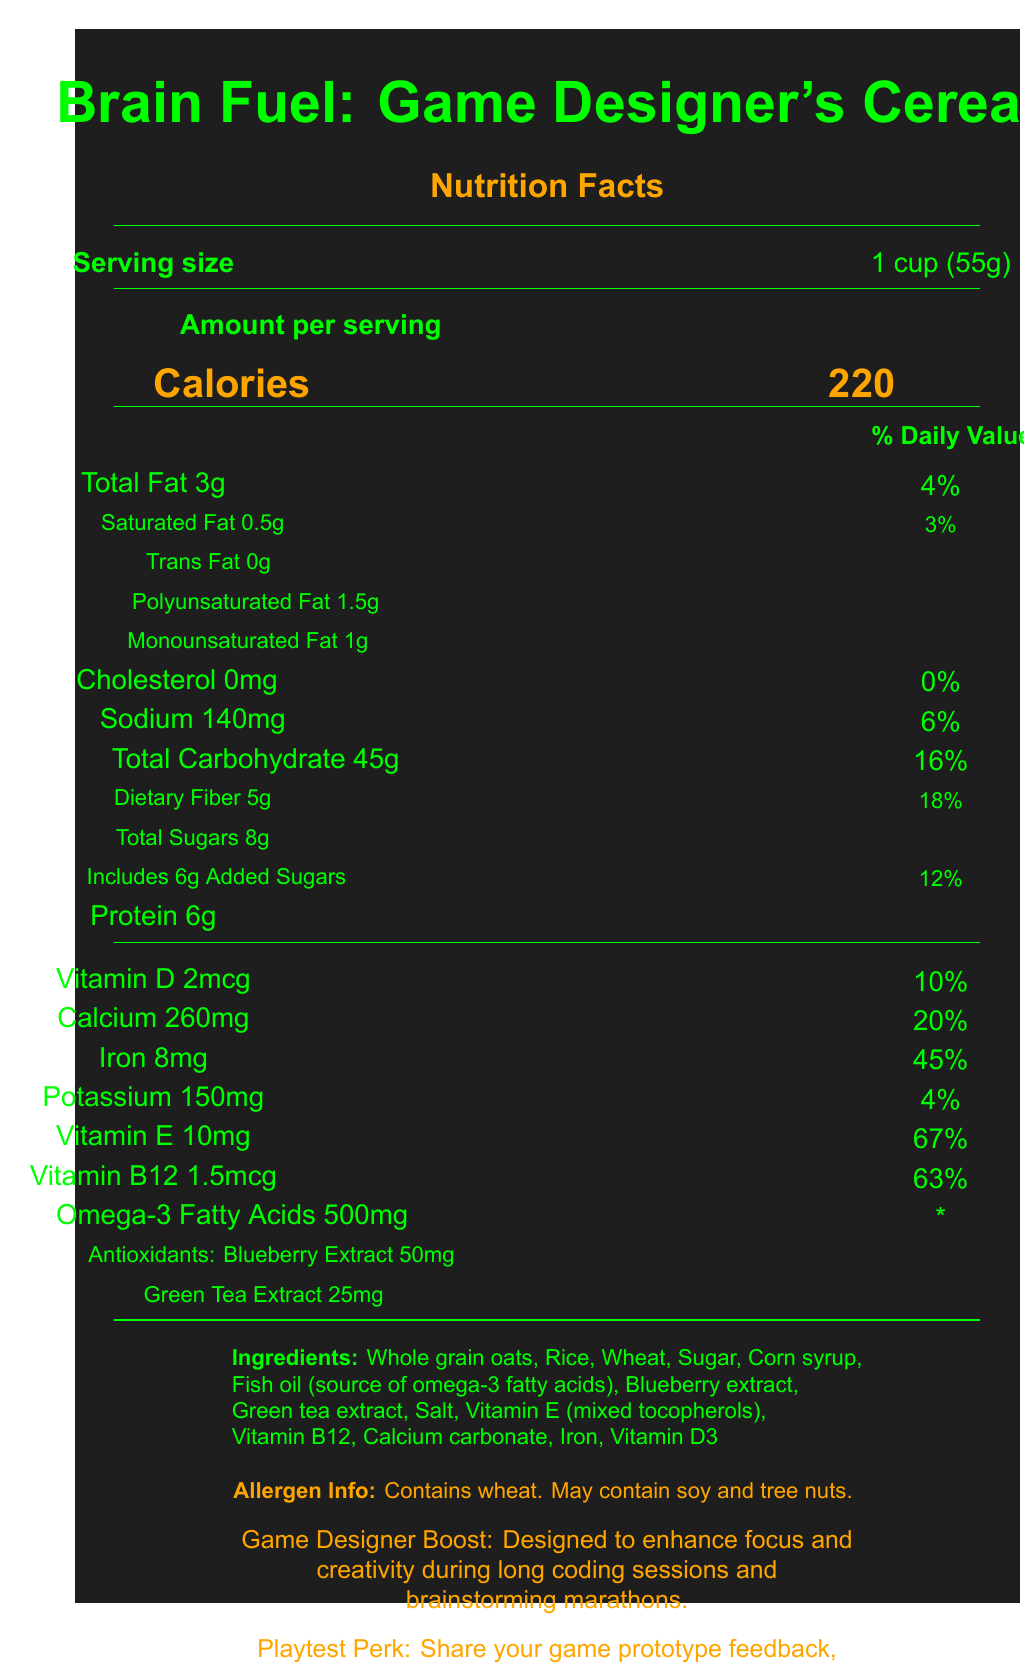what is the serving size? The serving size is explicitly listed as "1 cup (55g)" on the document.
Answer: 1 cup (55g) how many calories are there per serving? The calories per serving are clearly indicated as "220" in a large font.
Answer: 220 how much Vitamin B12 is in one serving? The document lists "Vitamin B12 1.5mcg" with a daily value percentage of 63%.
Answer: 1.5mcg how many grams of total fat are in one serving? The document states "Total Fat 3g" with a daily value percentage of 4%.
Answer: 3g which ingredient is the source of omega-3 fatty acids? The ingredient list includes "Fish oil (source of omega-3 fatty acids)".
Answer: Fish oil how much iron is in one serving? The document lists "Iron 8mg" with a daily value percentage of 45%.
Answer: 8mg what is the daily value percentage of Vitamin E per serving? The daily value of Vitamin E per serving is indicated as 67%.
Answer: 67% how many grams of dietary fiber are in one serving? The document states "Dietary Fiber 5g" with a daily value of 18%.
Answer: 5g how many servings per container? The document states "Servings per container: 12".
Answer: 12 how much blueberry extract is included in the antioxidants? A. 10mg B. 25mg C. 50mg The document specifies "Antioxidants: Blueberry Extract 50mg".
Answer: C. 50mg what is the daily value percentage for sodium per serving? A. 4% B. 6% C. 20% D. 12% The document lists "Sodium 140mg" with a daily value of 6%.
Answer: B. 6% how much protein is in one serving? A. 4g B. 5g C. 6g D. 8g The document lists "Protein 6g".
Answer: C. 6g is there any trans fat in this cereal? The document lists "Trans Fat 0g".
Answer: No does this cereal contain any cholesterol? The document lists "Cholesterol 0mg".
Answer: No what are the main features promoted by this cereal? The document states "Game Designer Boost: Designed to enhance focus and creativity during long coding sessions and brainstorming marathons".
Answer: Enhances focus and creativity during long coding sessions and brainstorming marathons. summarize the main idea of the document. The document details various nutritional facts and marketing features of "Brain Fuel: Game Designer's Cereal," highlighting its benefits for enhancing cognitive function and encouraging consumer engagement through feedback sharing.
Answer: The document provides the nutritional information for "Brain Fuel: Game Designer's Cereal." It lists the serving size, calories, daily values of various nutrients, and the ingredients, emphasizing its content of omega-3 fatty acids and antioxidants. The cereal is marketed to enhance focus and creativity for game designers, and provides a playtesting perk that offers a coupon for sharing feedback on game prototypes. how much monounsaturated fat is in one serving? The document lists "Monounsaturated Fat 1g."
Answer: 1g are there any allergen warnings associated with this cereal? The document includes an allergen info section that states, "Contains wheat. May contain soy and tree nuts."
Answer: Contains wheat. May contain soy and tree nuts. what is the total carbohydrate content per serving? The document lists "Total Carbohydrate 45g" with a daily value of 16%.
Answer: 45g how much green tea extract is included in the antioxidants? The document specifies "Green Tea Extract 25mg."
Answer: 25mg what is the omega-3 fatty acids content per serving? The document lists "Omega-3 Fatty Acids 500mg."
Answer: 500mg how long does the game developer gadget support last? The document does not provide any information about the duration of the support associated with the "Game Designer Boost."
Answer: Cannot be determined 